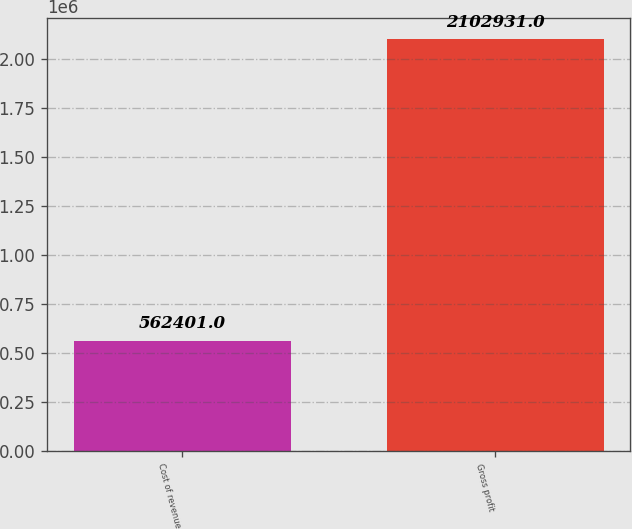Convert chart to OTSL. <chart><loc_0><loc_0><loc_500><loc_500><bar_chart><fcel>Cost of revenue<fcel>Gross profit<nl><fcel>562401<fcel>2.10293e+06<nl></chart> 